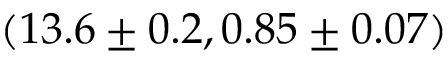<formula> <loc_0><loc_0><loc_500><loc_500>( 1 3 . 6 \pm 0 . 2 , 0 . 8 5 \pm 0 . 0 7 )</formula> 